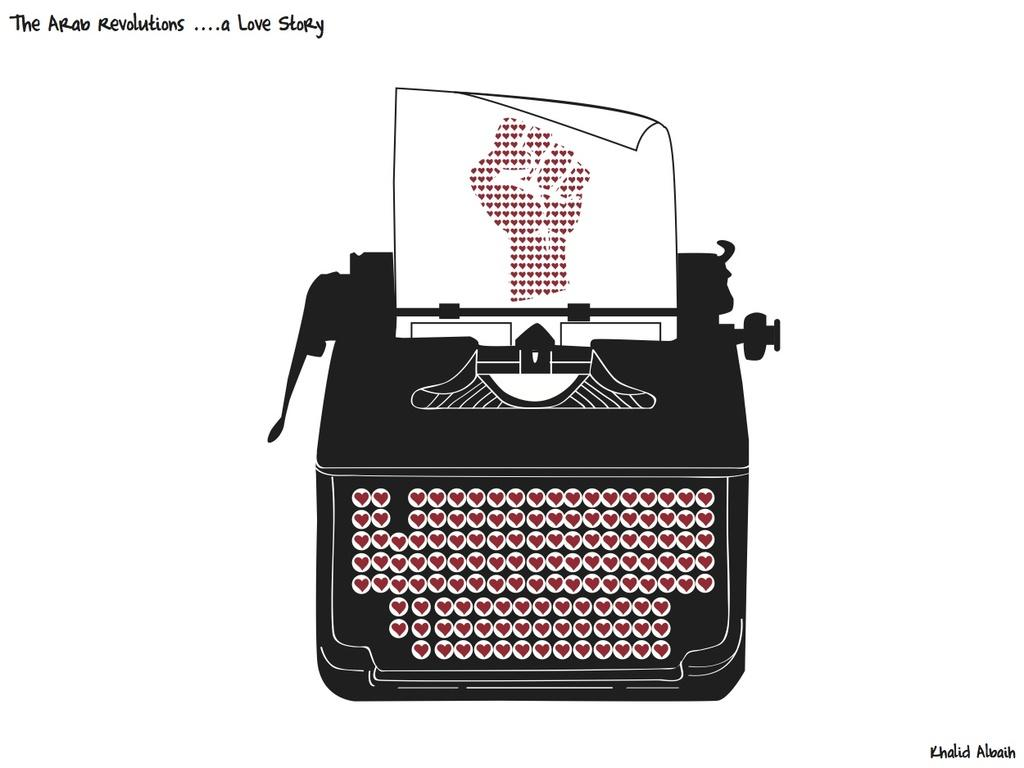What is the main subject of the image? The main subject of the image is a graphical image of a printing machine. What else can be seen in the image besides the printing machine? There is a paper and a hand depicted in the image. What is the hand doing in the image? The hand has hearts on the paper. What is the profit margin of the crime depicted in the image? There is no crime depicted in the image, and therefore no profit margin can be determined. 